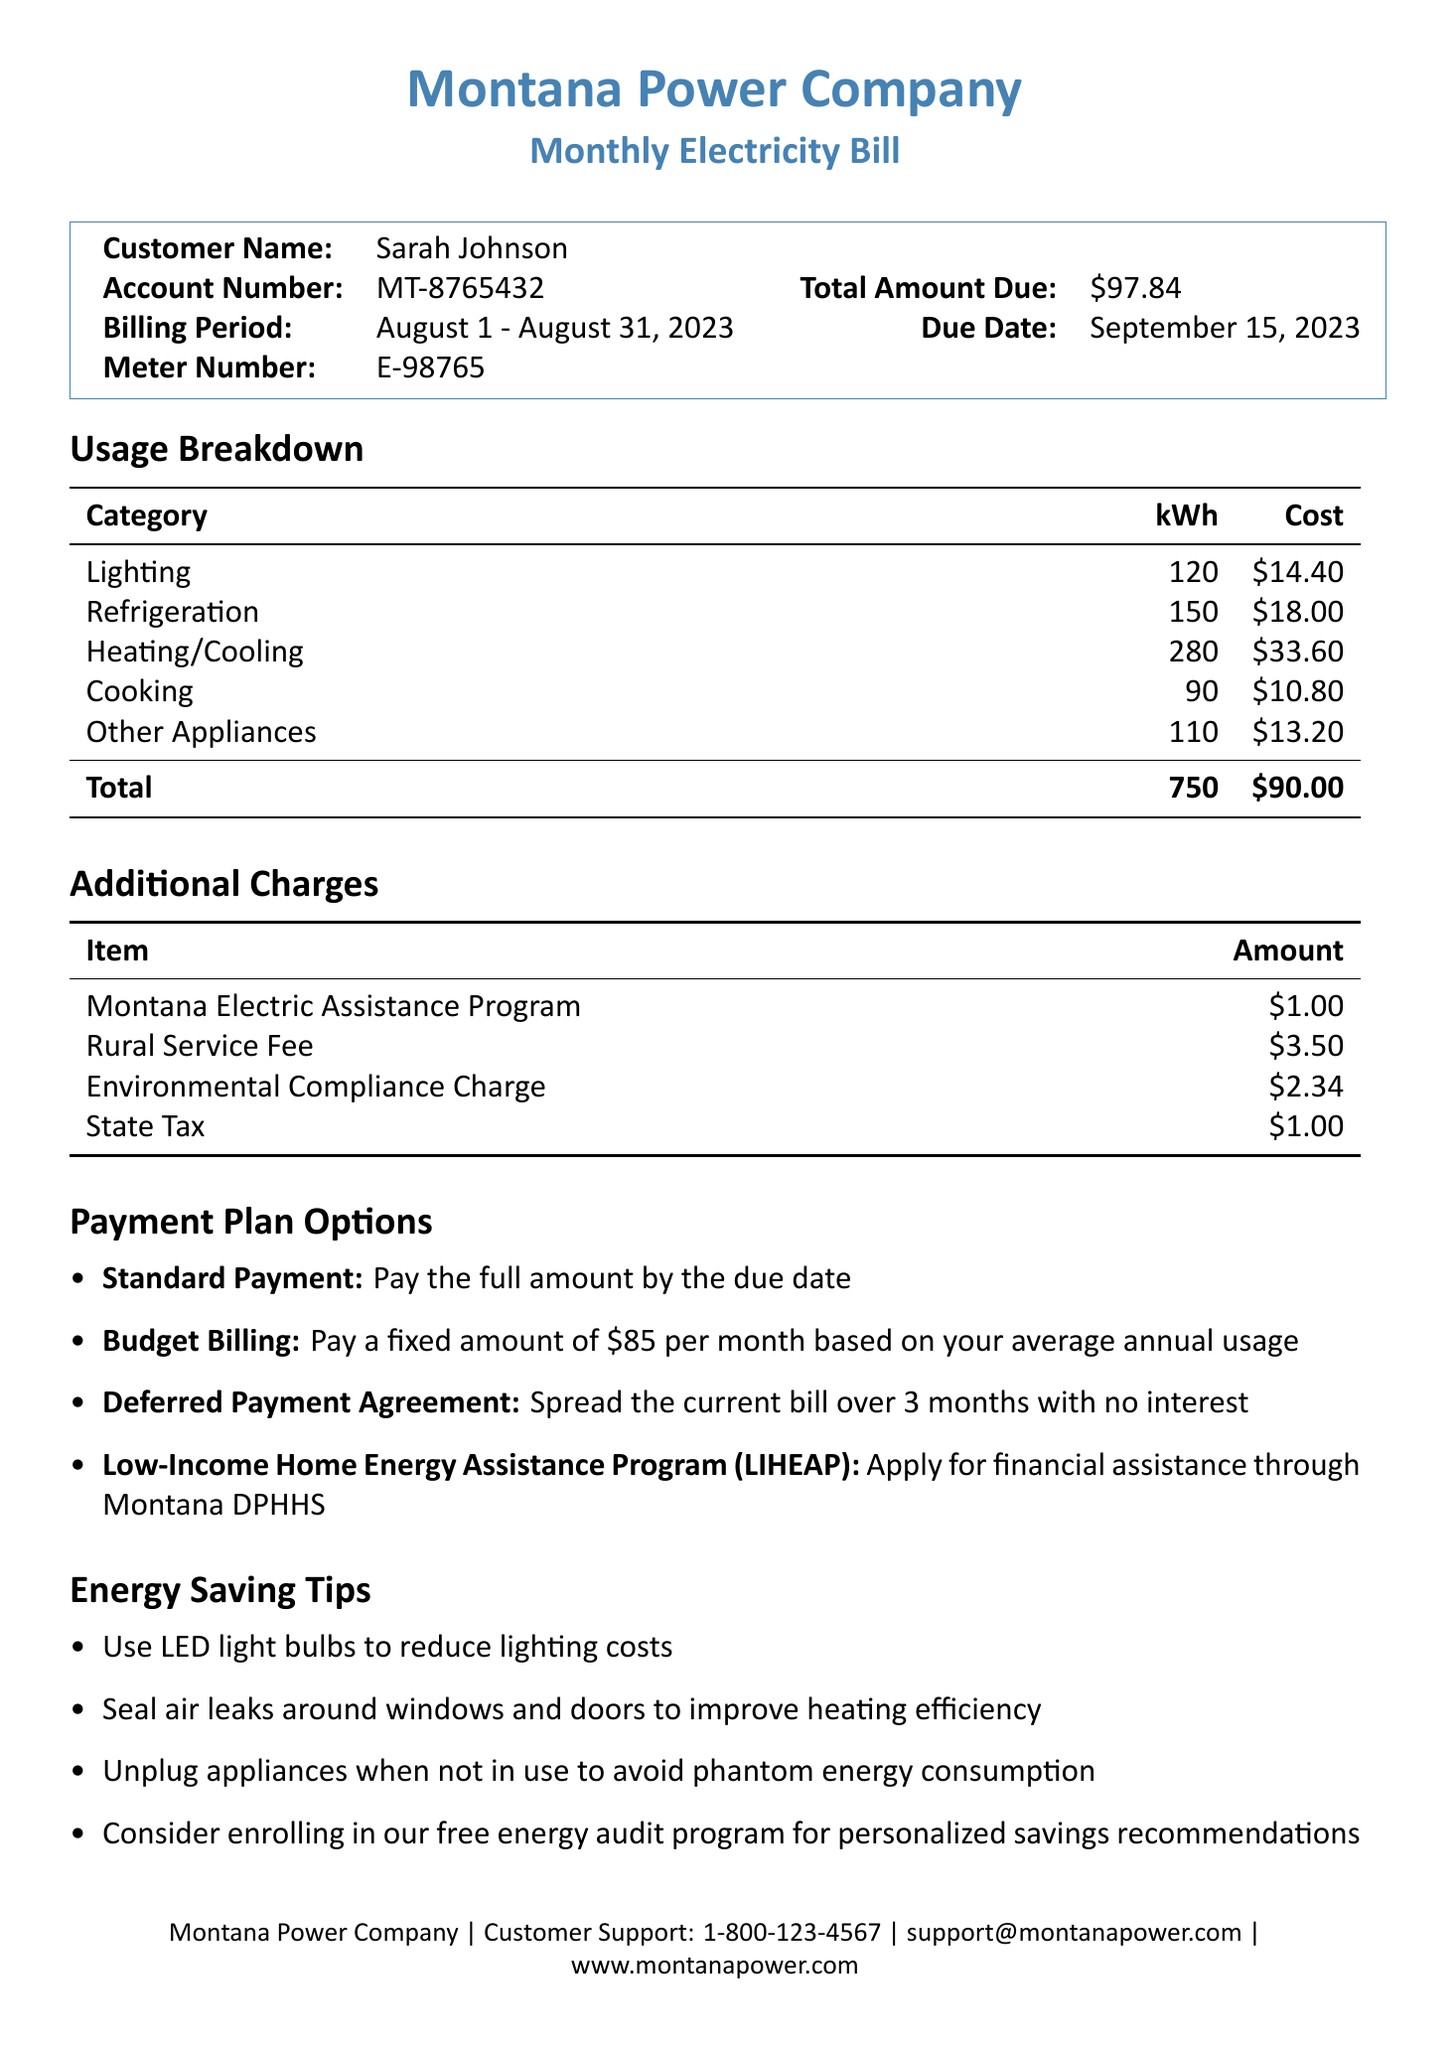What is the customer name? The customer name is listed at the top of the invoice.
Answer: Sarah Johnson What is the total amount due? The total amount due is mentioned in the financial section of the document.
Answer: $97.84 What is the billing period? The billing period is specified under the customer's details.
Answer: August 1 - August 31, 2023 How many kilowatt-hours (kWh) were used for heating/cooling? The document breaks down usage by category, including heating/cooling.
Answer: 280 What is one of the energy saving tips provided? The document lists various tips aimed at reducing energy costs.
Answer: Use LED light bulbs to reduce lighting costs What is the due date for payment? The due date is provided in the financial section of the invoice.
Answer: September 15, 2023 What is the total kWh usage? The total kWh usage is summarized at the bottom of the usage breakdown.
Answer: 750 What payment plan allows spreading the bill over three months? The payment plan options section describes different payment strategies.
Answer: Deferred Payment Agreement What item incurs a charge of $3.50? The additional charges section lists specific items with their associated costs.
Answer: Rural Service Fee 